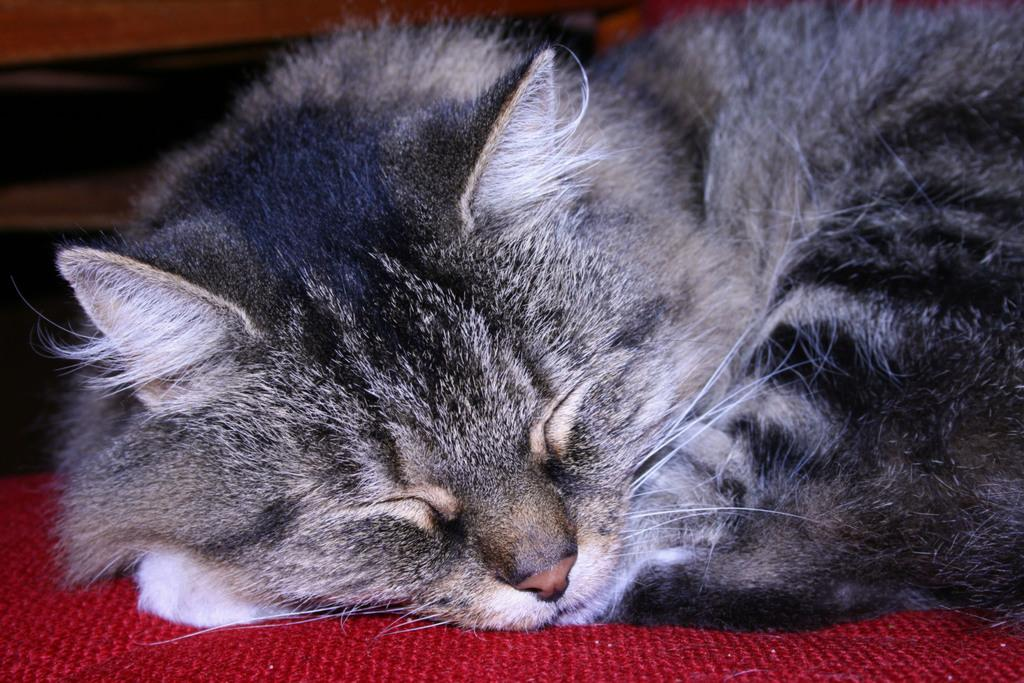What animal is present in the image? There is a cat in the image. What is the cat doing in the image? The cat is sleeping. What is the cat resting on in the image? The cat is on a red color mat. What color is the cat in the image? The cat is in black and white color. Can you see any leaves on the cat in the image? There are no leaves present on the cat in the image. Is the cat playing a guitar in the image? There is no guitar present in the image, and the cat is sleeping, not playing an instrument. 